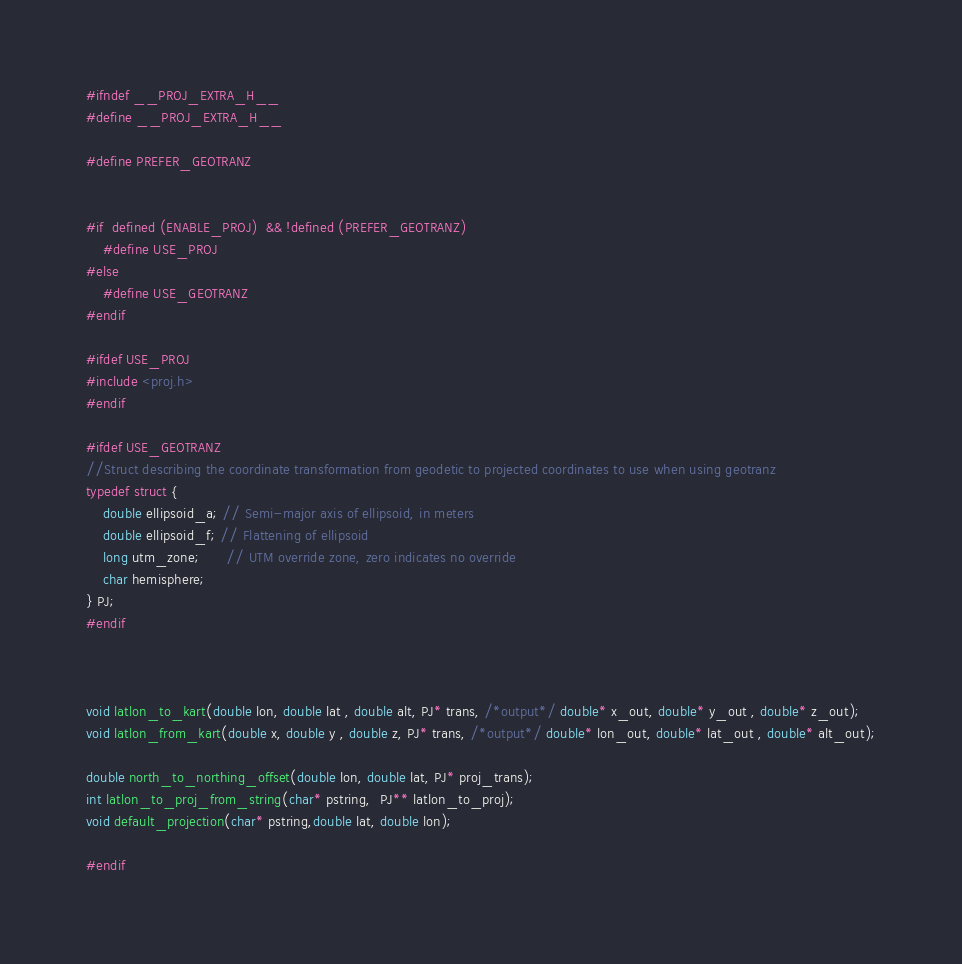Convert code to text. <code><loc_0><loc_0><loc_500><loc_500><_C_>#ifndef __PROJ_EXTRA_H__
#define __PROJ_EXTRA_H__

#define PREFER_GEOTRANZ


#if  defined (ENABLE_PROJ)  && !defined (PREFER_GEOTRANZ)
    #define USE_PROJ
#else
    #define USE_GEOTRANZ
#endif

#ifdef USE_PROJ
#include <proj.h>
#endif

#ifdef USE_GEOTRANZ
//Struct describing the coordinate transformation from geodetic to projected coordinates to use when using geotranz
typedef struct { 
    double ellipsoid_a; // Semi-major axis of ellipsoid, in meters
    double ellipsoid_f; // Flattening of ellipsoid
    long utm_zone;      // UTM override zone, zero indicates no override
    char hemisphere;
} PJ;
#endif



void latlon_to_kart(double lon, double lat , double alt, PJ* trans, /*output*/ double* x_out, double* y_out , double* z_out);
void latlon_from_kart(double x, double y , double z, PJ* trans, /*output*/ double* lon_out, double* lat_out , double* alt_out);

double north_to_northing_offset(double lon, double lat, PJ* proj_trans);
int latlon_to_proj_from_string(char* pstring,  PJ** latlon_to_proj);
void default_projection(char* pstring,double lat, double lon);

#endif
</code> 